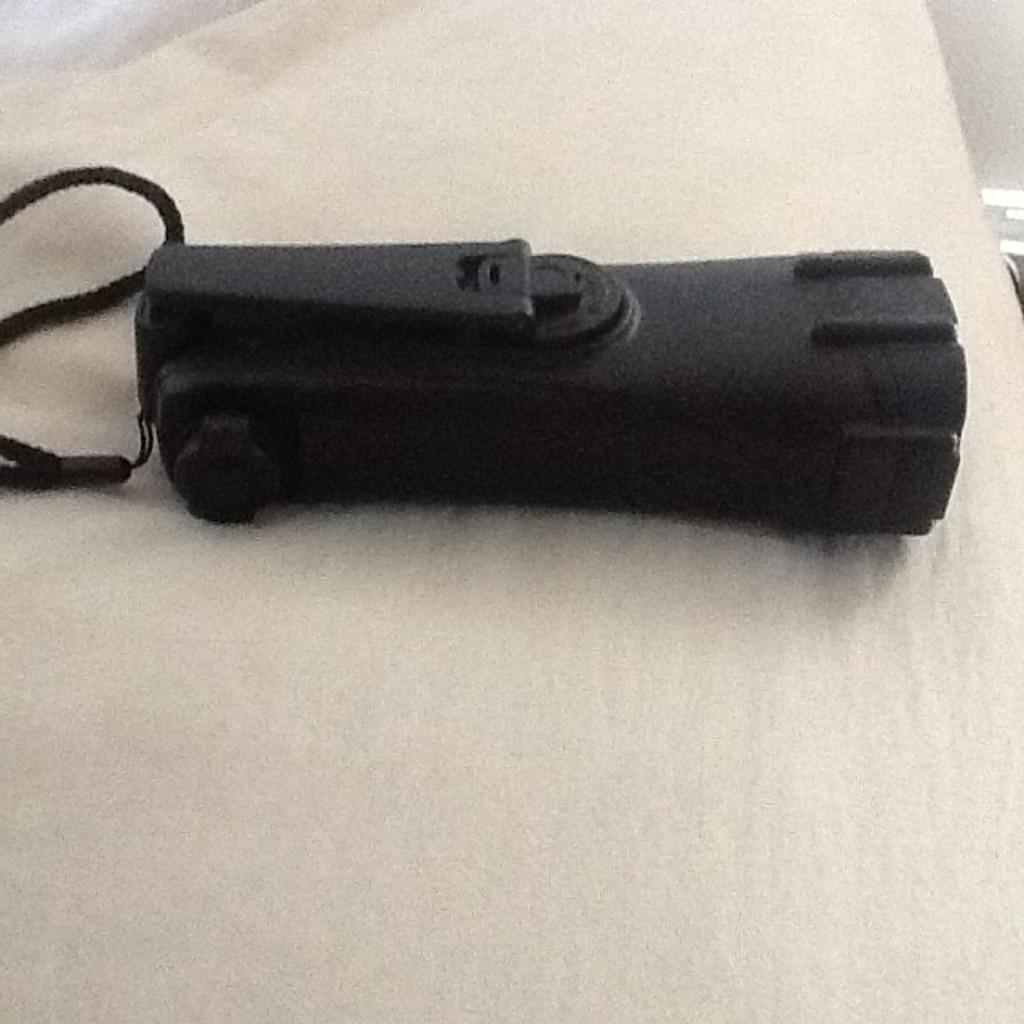In one or two sentences, can you explain what this image depicts? In the center of the image we can see a torch placed on the cloth. 